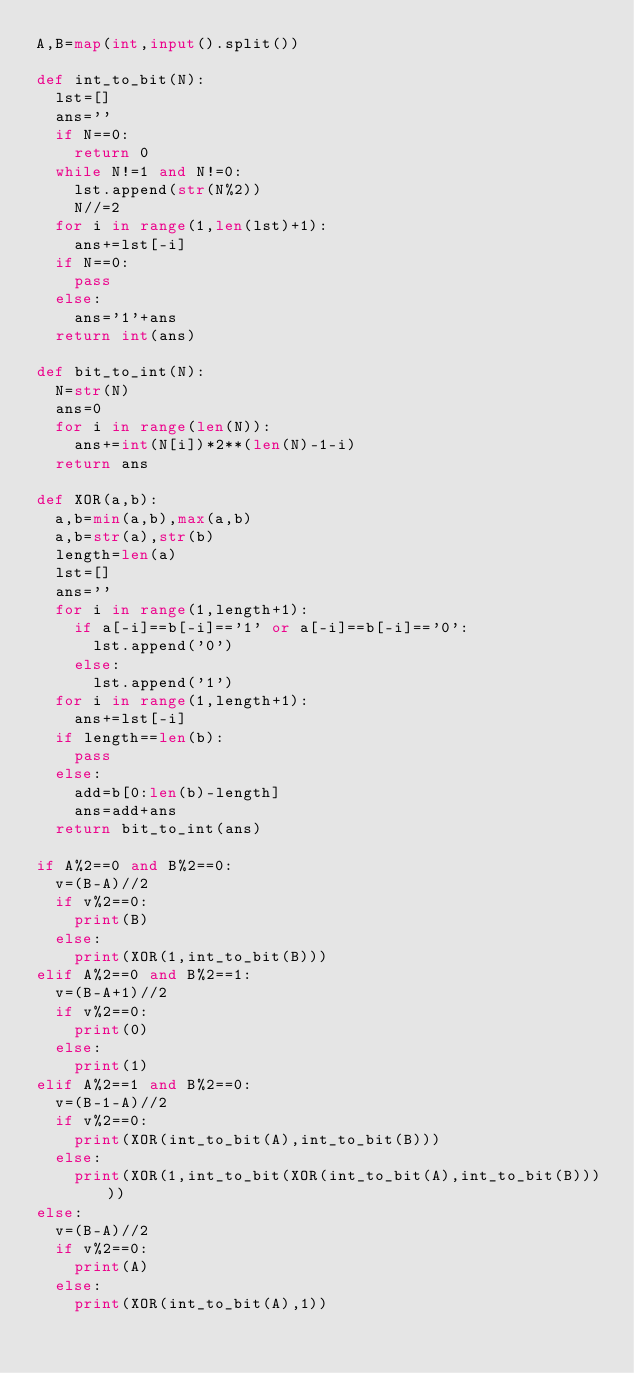<code> <loc_0><loc_0><loc_500><loc_500><_Python_>A,B=map(int,input().split())

def int_to_bit(N):
  lst=[]
  ans=''
  if N==0:
    return 0
  while N!=1 and N!=0:
    lst.append(str(N%2))
    N//=2
  for i in range(1,len(lst)+1):
    ans+=lst[-i]
  if N==0:
    pass
  else:
    ans='1'+ans
  return int(ans)

def bit_to_int(N):
  N=str(N)
  ans=0
  for i in range(len(N)):
    ans+=int(N[i])*2**(len(N)-1-i)
  return ans

def XOR(a,b):
  a,b=min(a,b),max(a,b)
  a,b=str(a),str(b)
  length=len(a)
  lst=[]
  ans=''
  for i in range(1,length+1):
    if a[-i]==b[-i]=='1' or a[-i]==b[-i]=='0':
      lst.append('0')
    else:
      lst.append('1')
  for i in range(1,length+1):        
    ans+=lst[-i]
  if length==len(b):
    pass
  else:
    add=b[0:len(b)-length]
    ans=add+ans
  return bit_to_int(ans)

if A%2==0 and B%2==0:
  v=(B-A)//2
  if v%2==0:
    print(B)
  else:
    print(XOR(1,int_to_bit(B)))
elif A%2==0 and B%2==1:
  v=(B-A+1)//2
  if v%2==0:
    print(0)
  else:
    print(1)
elif A%2==1 and B%2==0:
  v=(B-1-A)//2
  if v%2==0:
    print(XOR(int_to_bit(A),int_to_bit(B)))
  else:
    print(XOR(1,int_to_bit(XOR(int_to_bit(A),int_to_bit(B)))))
else:
  v=(B-A)//2
  if v%2==0:
    print(A)
  else:
    print(XOR(int_to_bit(A),1))</code> 